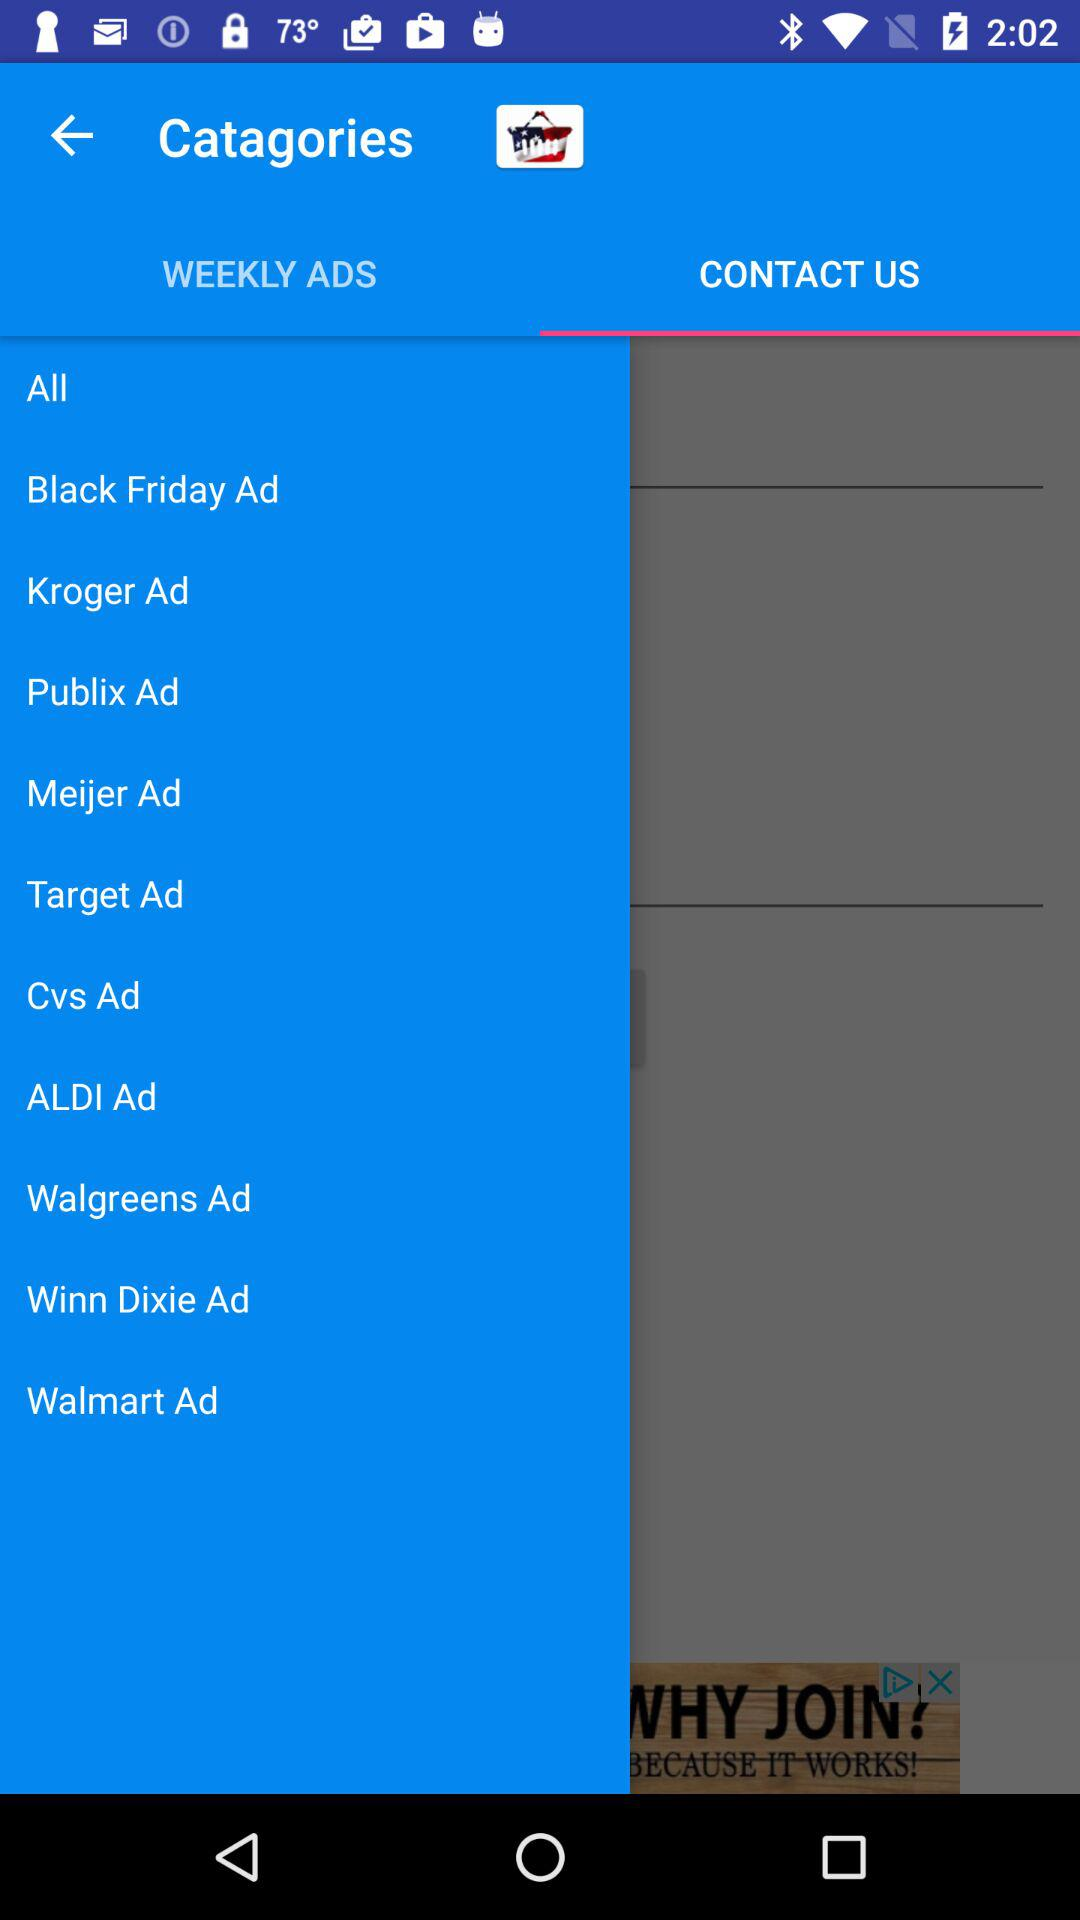What is the selected tab? The selected tab is "CONTACT US". 